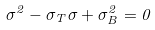<formula> <loc_0><loc_0><loc_500><loc_500>\sigma ^ { 2 } - \sigma _ { T } \sigma + \sigma _ { B } ^ { 2 } = 0</formula> 